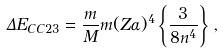<formula> <loc_0><loc_0><loc_500><loc_500>\Delta E _ { C C 2 3 } = \frac { m } { M } m ( Z \alpha ) ^ { 4 } \left \{ \frac { 3 } { 8 n ^ { 4 } } \right \} \, ,</formula> 